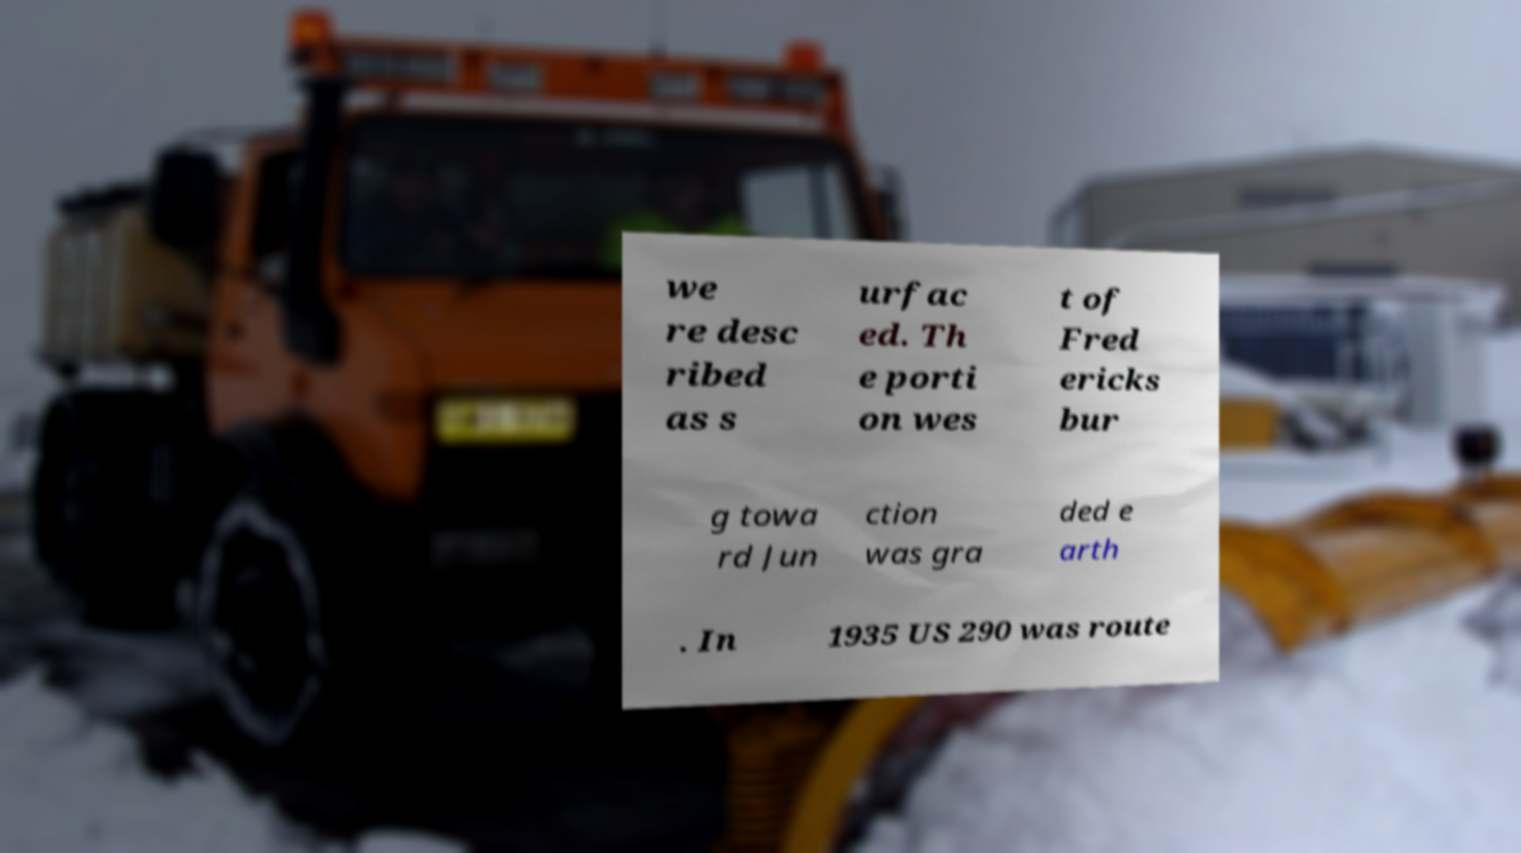For documentation purposes, I need the text within this image transcribed. Could you provide that? we re desc ribed as s urfac ed. Th e porti on wes t of Fred ericks bur g towa rd Jun ction was gra ded e arth . In 1935 US 290 was route 